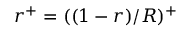Convert formula to latex. <formula><loc_0><loc_0><loc_500><loc_500>r ^ { + } = ( ( 1 - r ) / R ) ^ { + }</formula> 